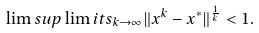<formula> <loc_0><loc_0><loc_500><loc_500>& \lim s u p \lim i t s _ { k \rightarrow \infty } \| x ^ { k } - x ^ { * } \| ^ { \frac { 1 } { k } } < 1 .</formula> 